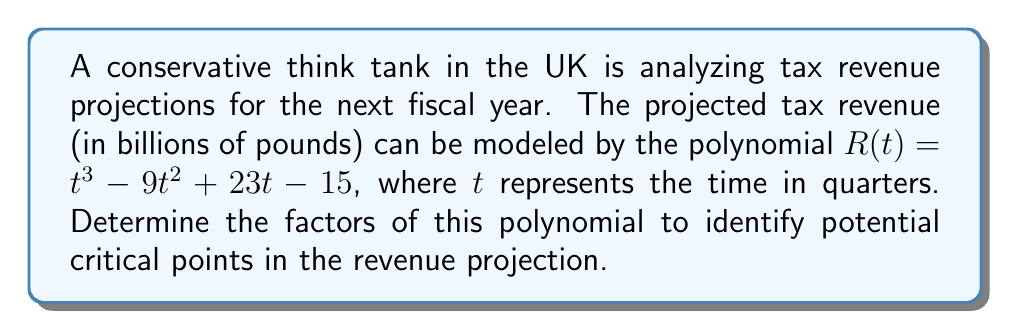What is the answer to this math problem? To factor this polynomial, we'll follow these steps:

1) First, let's check if there are any rational roots using the rational root theorem. The possible rational roots are the factors of the constant term (15): ±1, ±3, ±5, ±15.

2) Testing these values, we find that $R(1) = 0$. So $(t-1)$ is a factor.

3) We can use polynomial long division to divide $R(t)$ by $(t-1)$:

   $t^3 - 9t^2 + 23t - 15 = (t-1)(t^2 - 8t + 15)$

4) Now we need to factor the quadratic $t^2 - 8t + 15$. We can do this by finding two numbers that multiply to give 15 and add to give -8. These numbers are -3 and -5.

5) Therefore, $t^2 - 8t + 15 = (t-3)(t-5)$

6) Combining all factors, we get:

   $R(t) = (t-1)(t-3)(t-5)$

This factorization reveals that the revenue function has roots at $t=1$, $t=3$, and $t=5$, corresponding to the end of the first, third, and fifth quarters respectively. These could represent critical points in the revenue projection.
Answer: $R(t) = (t-1)(t-3)(t-5)$ 